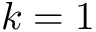<formula> <loc_0><loc_0><loc_500><loc_500>k = 1</formula> 